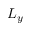Convert formula to latex. <formula><loc_0><loc_0><loc_500><loc_500>L _ { y }</formula> 